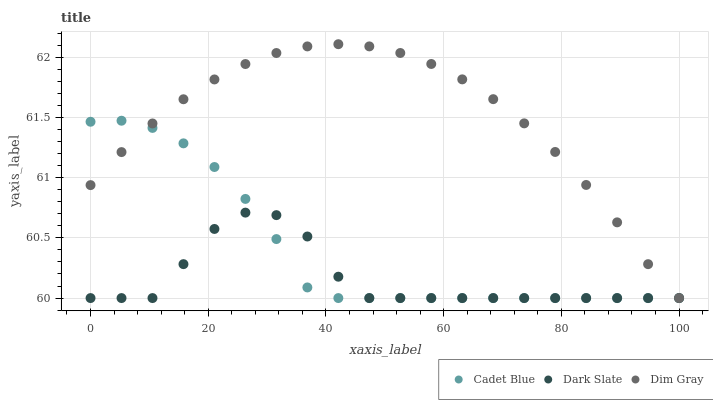Does Dark Slate have the minimum area under the curve?
Answer yes or no. Yes. Does Dim Gray have the maximum area under the curve?
Answer yes or no. Yes. Does Cadet Blue have the minimum area under the curve?
Answer yes or no. No. Does Cadet Blue have the maximum area under the curve?
Answer yes or no. No. Is Dim Gray the smoothest?
Answer yes or no. Yes. Is Dark Slate the roughest?
Answer yes or no. Yes. Is Cadet Blue the smoothest?
Answer yes or no. No. Is Cadet Blue the roughest?
Answer yes or no. No. Does Dark Slate have the lowest value?
Answer yes or no. Yes. Does Dim Gray have the highest value?
Answer yes or no. Yes. Does Cadet Blue have the highest value?
Answer yes or no. No. Does Cadet Blue intersect Dim Gray?
Answer yes or no. Yes. Is Cadet Blue less than Dim Gray?
Answer yes or no. No. Is Cadet Blue greater than Dim Gray?
Answer yes or no. No. 